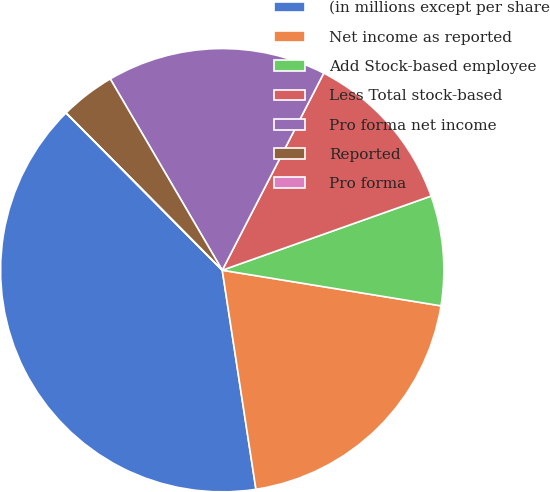Convert chart. <chart><loc_0><loc_0><loc_500><loc_500><pie_chart><fcel>(in millions except per share<fcel>Net income as reported<fcel>Add Stock-based employee<fcel>Less Total stock-based<fcel>Pro forma net income<fcel>Reported<fcel>Pro forma<nl><fcel>39.98%<fcel>20.0%<fcel>8.0%<fcel>12.0%<fcel>16.0%<fcel>4.01%<fcel>0.01%<nl></chart> 